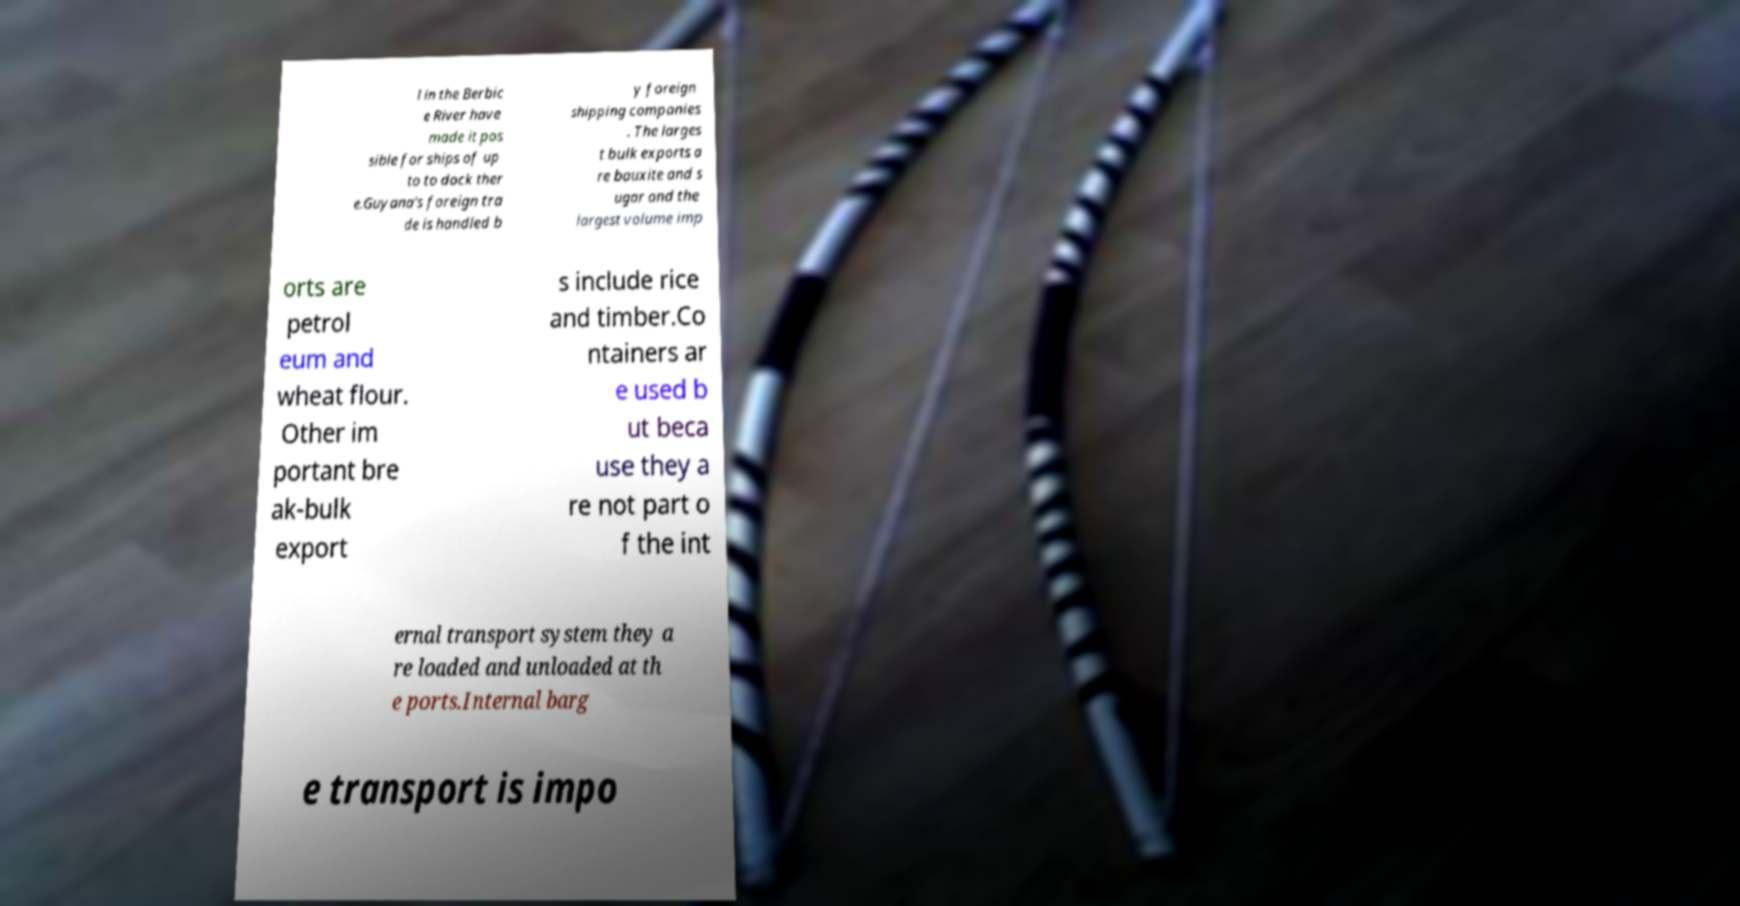Please identify and transcribe the text found in this image. l in the Berbic e River have made it pos sible for ships of up to to dock ther e.Guyana's foreign tra de is handled b y foreign shipping companies . The larges t bulk exports a re bauxite and s ugar and the largest volume imp orts are petrol eum and wheat flour. Other im portant bre ak-bulk export s include rice and timber.Co ntainers ar e used b ut beca use they a re not part o f the int ernal transport system they a re loaded and unloaded at th e ports.Internal barg e transport is impo 